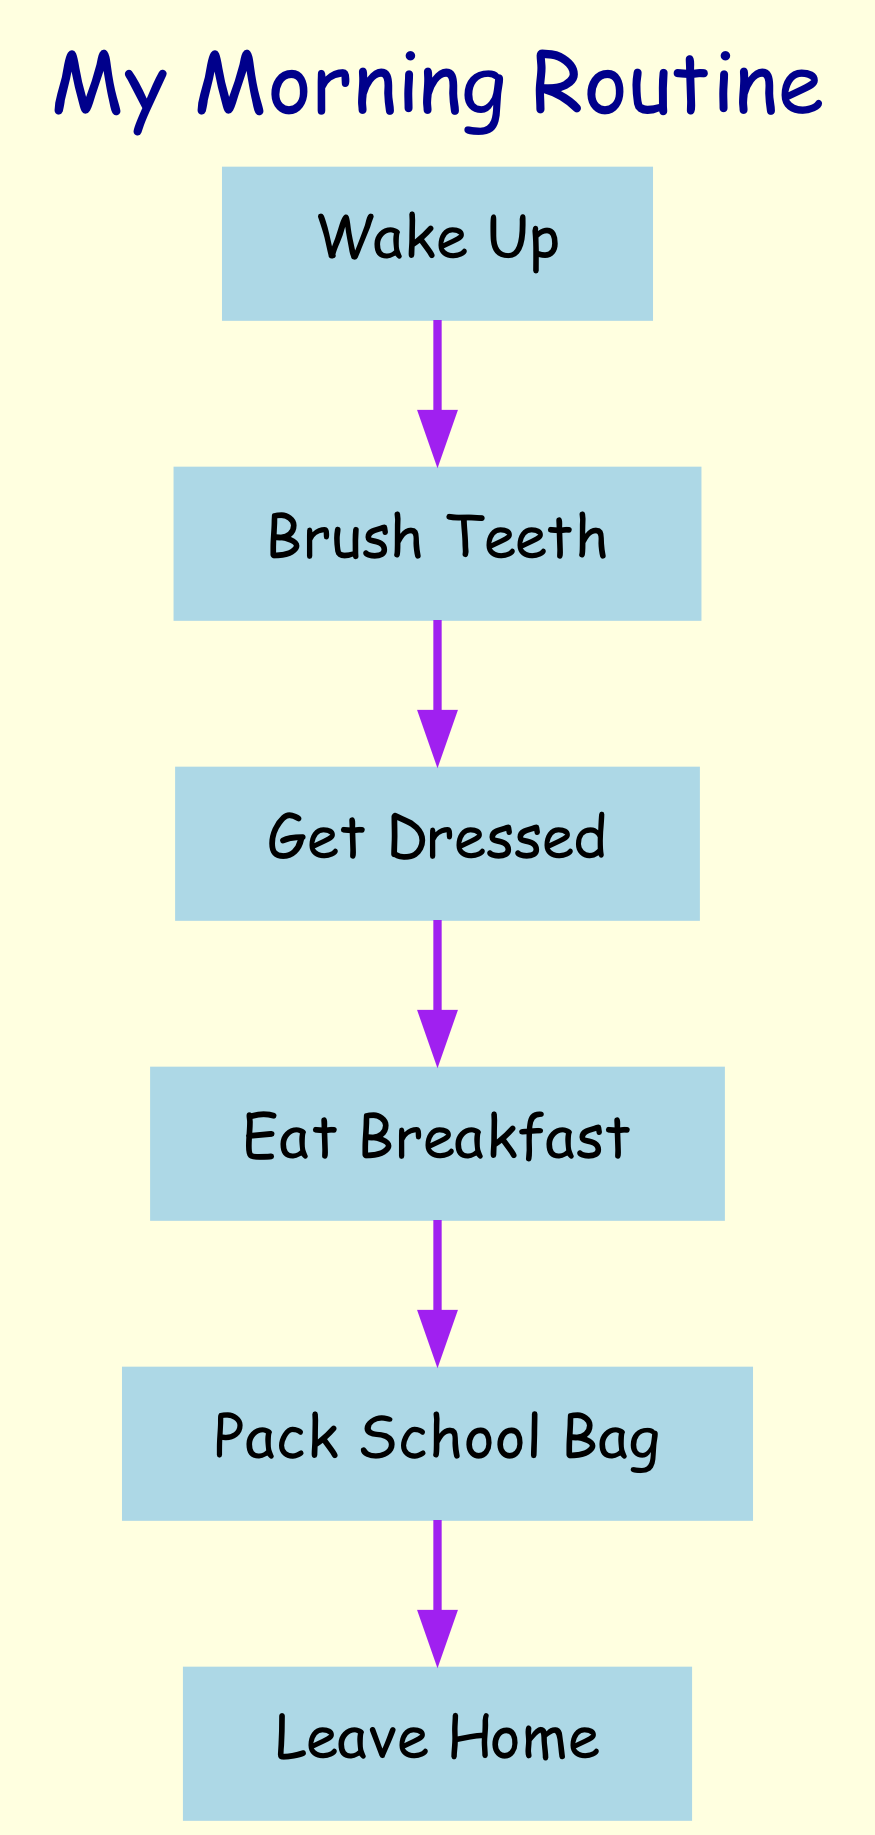What is the first step in the morning routine? The diagram shows that the first node is "Wake Up". Therefore, this is the initial action in the morning routine.
Answer: Wake Up How many steps are there in the morning routine? The diagram lists a total of six nodes: Wake Up, Brush Teeth, Get Dressed, Eat Breakfast, Pack School Bag, and Leave Home. Therefore, there are six steps in the morning routine.
Answer: 6 What action follows "Brush Teeth"? The edge from "Brush Teeth" points to "Get Dressed", indicating that after brushing teeth, you proceed to get dressed.
Answer: Get Dressed Which step comes directly before "Pack School Bag"? The arrow from "Eat Breakfast" to "Pack School Bag" shows that "Eat Breakfast" is the step immediately before packing the school bag.
Answer: Eat Breakfast What action occurs just before leaving home? The diagram shows that "Pack School Bag" is the last action before "Leave Home". This means packing the school bag happens right before leaving for school.
Answer: Pack School Bag What is the main activity described in the second step of the routine? In the second node, "Brush Teeth" is described, indicating that this step focuses on cleaning the teeth.
Answer: Brush Teeth Is "Get Dressed" the last step in the morning routine? By reviewing the flow, "Get Dressed" is followed by "Eat Breakfast", indicating that it is not the last step. Hence, it is not the final action in the routine.
Answer: No How many edges connect the nodes in the diagram? Each step flows to the next, creating five connections from the six nodes (one less than the total number of nodes), resulting in five edges connecting them.
Answer: 5 What is the last action in the morning routine according to the diagram? The diagram ends with "Leave Home", which is the last action taken in the sequence of the morning routine.
Answer: Leave Home 